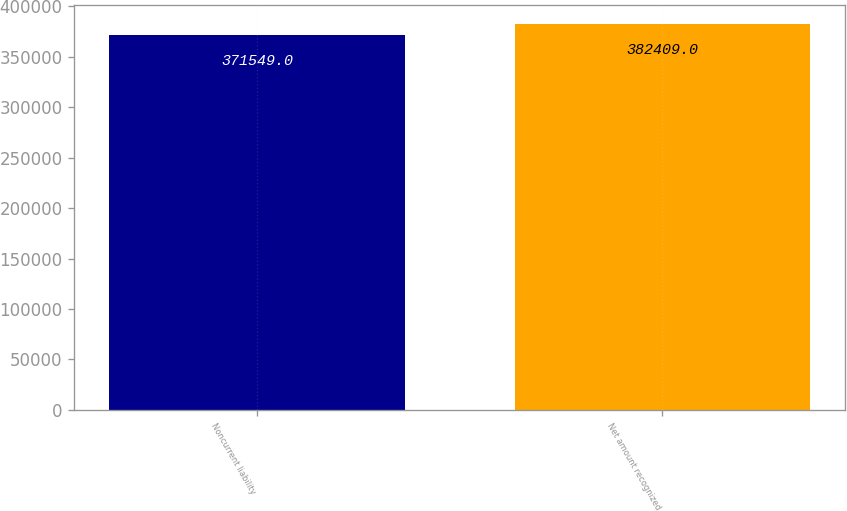Convert chart to OTSL. <chart><loc_0><loc_0><loc_500><loc_500><bar_chart><fcel>Noncurrent liability<fcel>Net amount recognized<nl><fcel>371549<fcel>382409<nl></chart> 